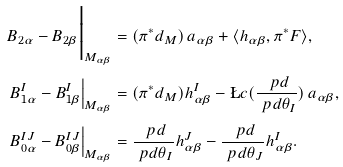<formula> <loc_0><loc_0><loc_500><loc_500>B _ { 2 \alpha } - B _ { 2 \beta } \Big | _ { M _ { \alpha \beta } } & = ( \pi ^ { * } d _ { M } ) \, a _ { \alpha \beta } + \langle h _ { \alpha \beta } , \pi ^ { * } F \rangle , \\ B _ { 1 \alpha } ^ { I } - B _ { 1 \beta } ^ { I } \Big | _ { M _ { \alpha \beta } } & = ( \pi ^ { * } d _ { M } ) h _ { \alpha \beta } ^ { I } - \L c ( \frac { \ p d } { \ p d \theta _ { I } } ) \, a _ { \alpha \beta } , \\ B _ { 0 \alpha } ^ { I J } - B _ { 0 \beta } ^ { I J } \Big | _ { M _ { \alpha \beta } } & = \frac { \ p d } { \ p d \theta _ { I } } h ^ { J } _ { \alpha \beta } - \frac { \ p d } { \ p d \theta _ { J } } h ^ { I } _ { \alpha \beta } .</formula> 